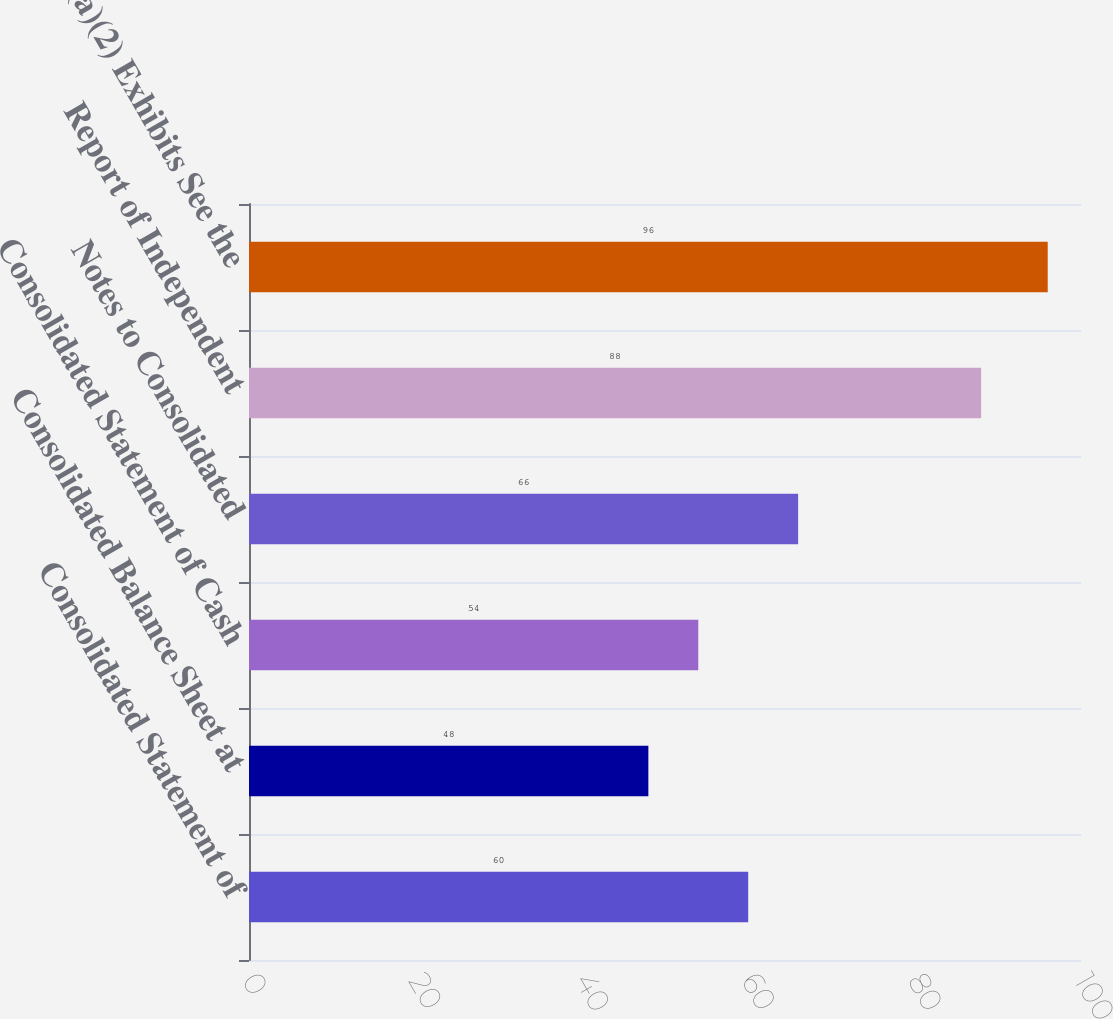Convert chart to OTSL. <chart><loc_0><loc_0><loc_500><loc_500><bar_chart><fcel>Consolidated Statement of<fcel>Consolidated Balance Sheet at<fcel>Consolidated Statement of Cash<fcel>Notes to Consolidated<fcel>Report of Independent<fcel>(a)(2) Exhibits See the<nl><fcel>60<fcel>48<fcel>54<fcel>66<fcel>88<fcel>96<nl></chart> 